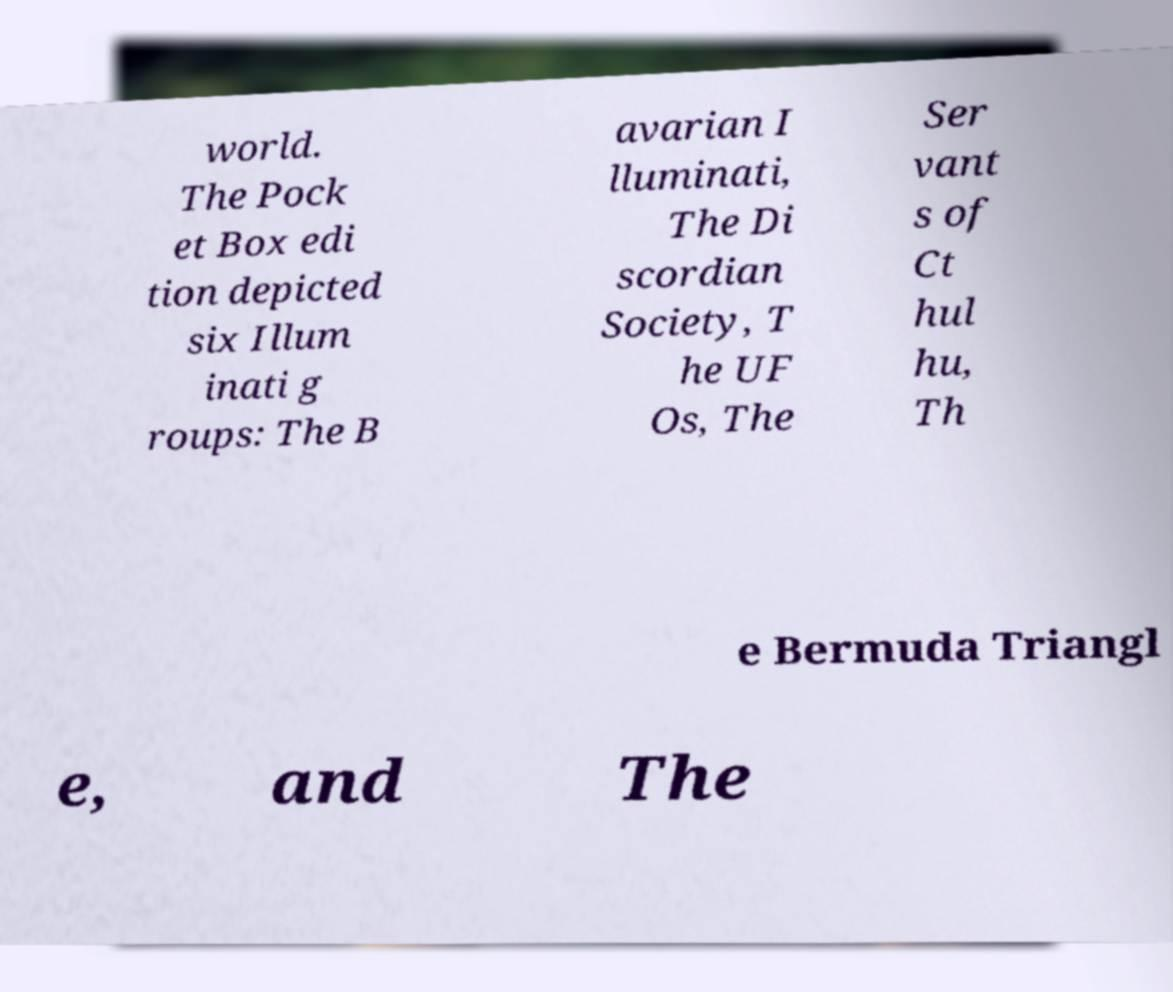Can you read and provide the text displayed in the image?This photo seems to have some interesting text. Can you extract and type it out for me? world. The Pock et Box edi tion depicted six Illum inati g roups: The B avarian I lluminati, The Di scordian Society, T he UF Os, The Ser vant s of Ct hul hu, Th e Bermuda Triangl e, and The 